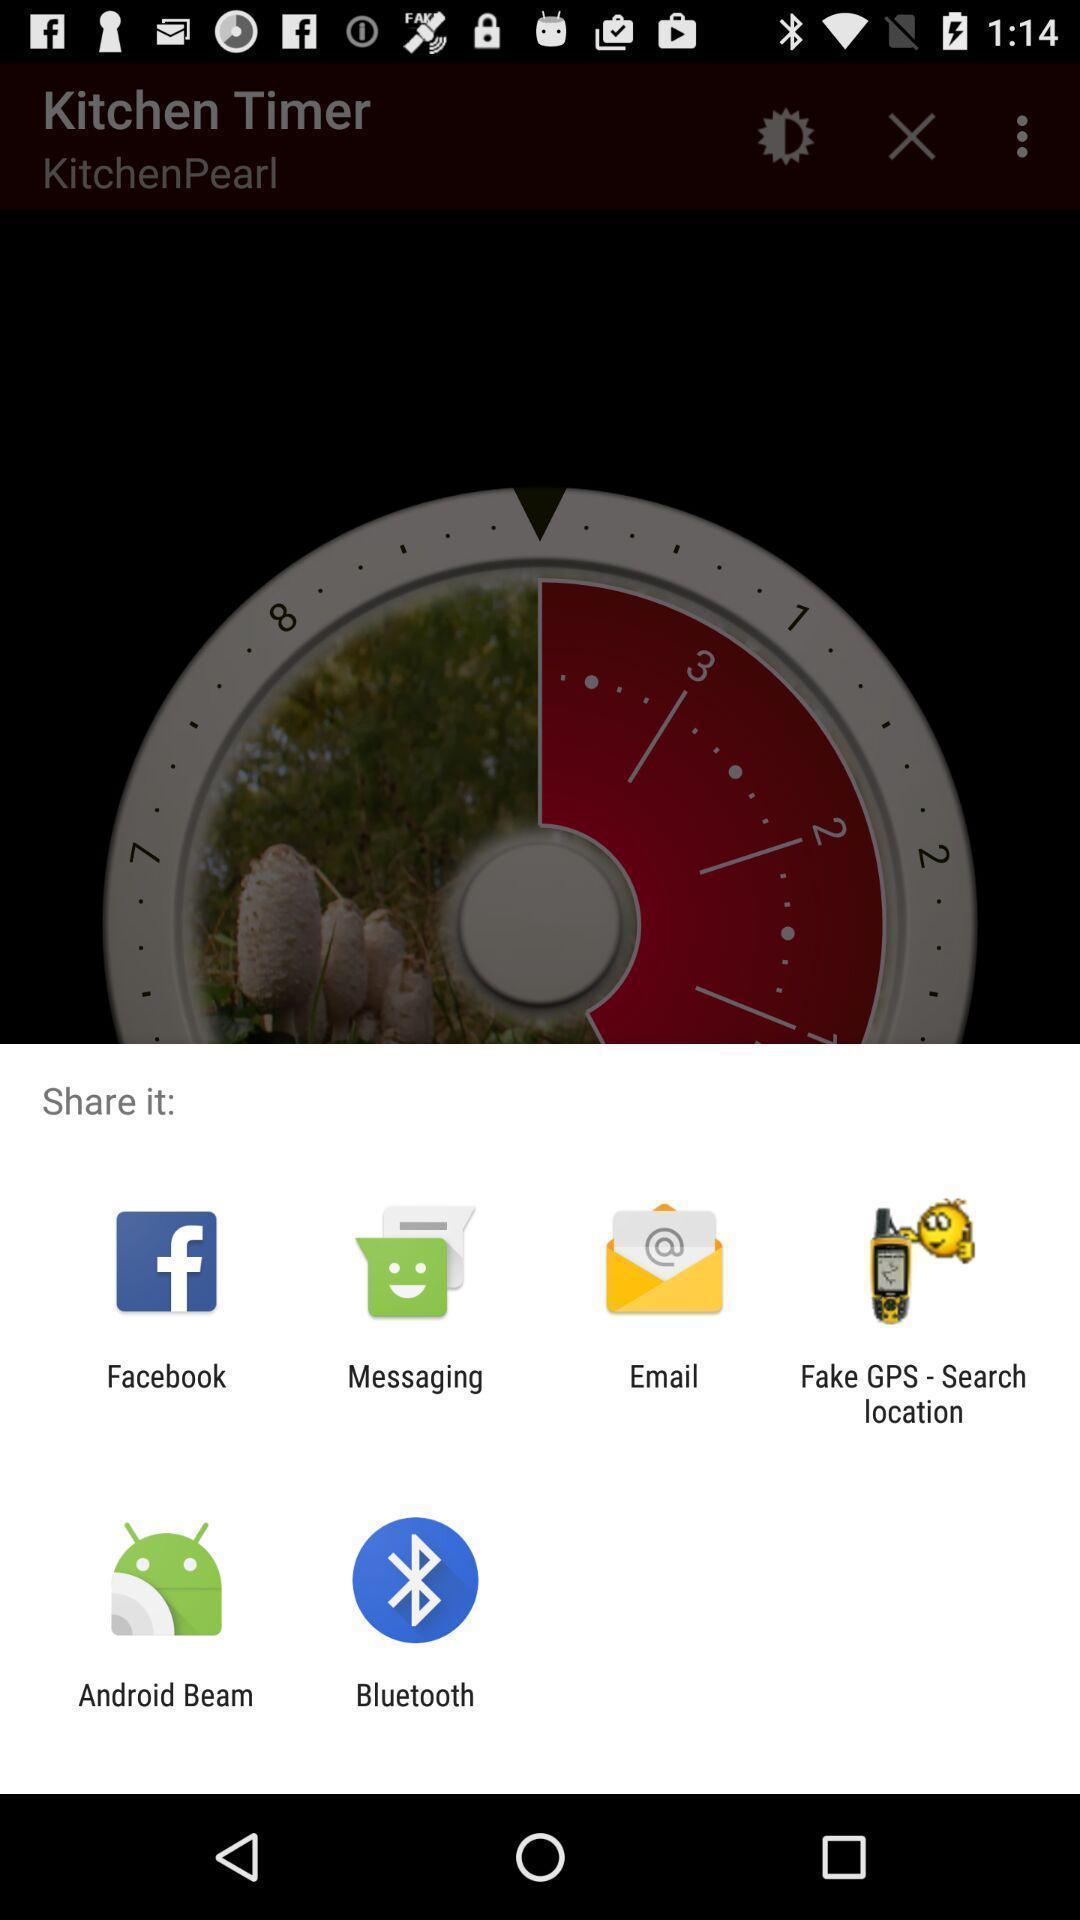Describe this image in words. Share information with different apps. 